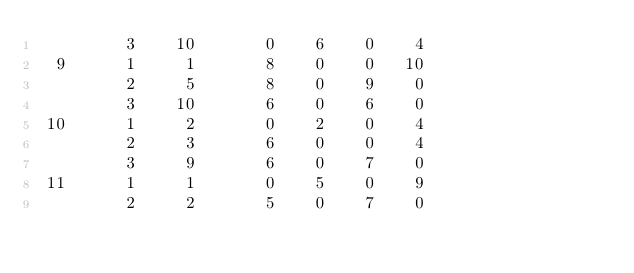<code> <loc_0><loc_0><loc_500><loc_500><_ObjectiveC_>         3    10       0    6    0    4
  9      1     1       8    0    0   10
         2     5       8    0    9    0
         3    10       6    0    6    0
 10      1     2       0    2    0    4
         2     3       6    0    0    4
         3     9       6    0    7    0
 11      1     1       0    5    0    9
         2     2       5    0    7    0</code> 